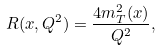<formula> <loc_0><loc_0><loc_500><loc_500>R ( x , Q ^ { 2 } ) = \frac { 4 m _ { T } ^ { 2 } ( x ) } { Q ^ { 2 } } ,</formula> 